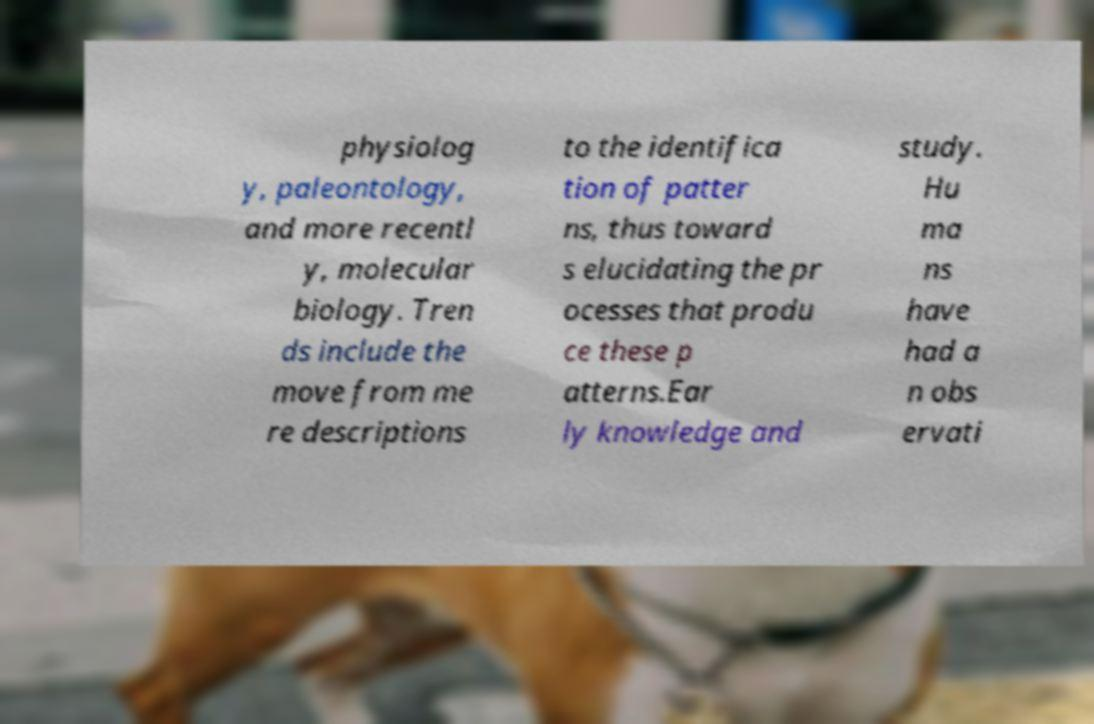Could you assist in decoding the text presented in this image and type it out clearly? physiolog y, paleontology, and more recentl y, molecular biology. Tren ds include the move from me re descriptions to the identifica tion of patter ns, thus toward s elucidating the pr ocesses that produ ce these p atterns.Ear ly knowledge and study. Hu ma ns have had a n obs ervati 